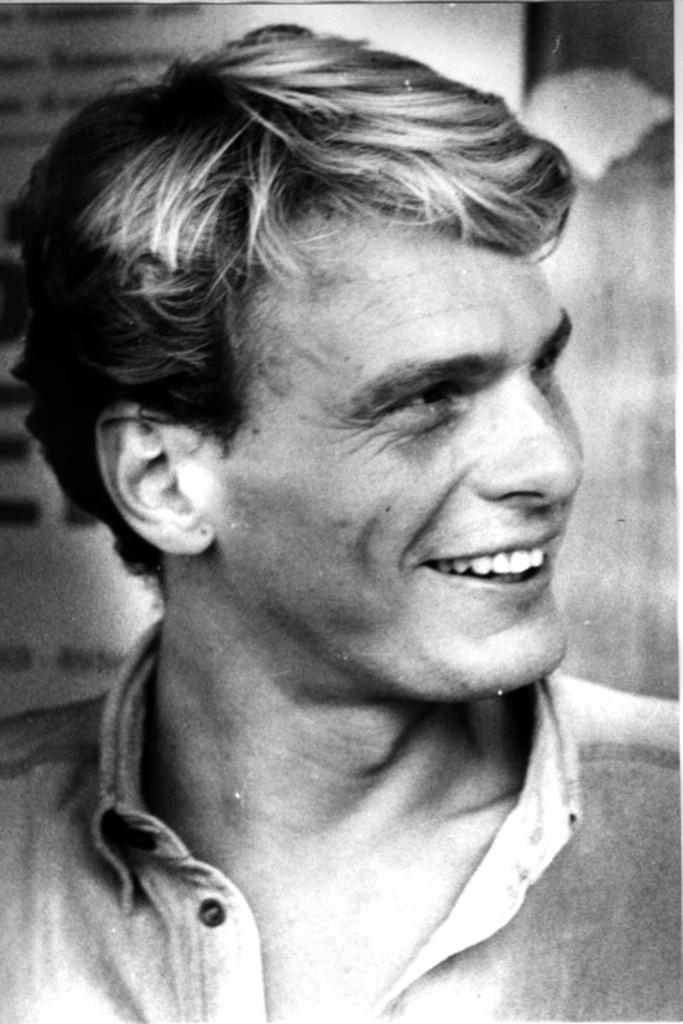What is the color scheme of the image? The image is black and white. What is the main subject of the image? There is a close-up view of a person's face in the image. What expression does the person have in the image? The person is smiling in the image. What book is the person reading in the image? There is no book or reading activity present in the image; it is a close-up view of a person's face with a smile. 